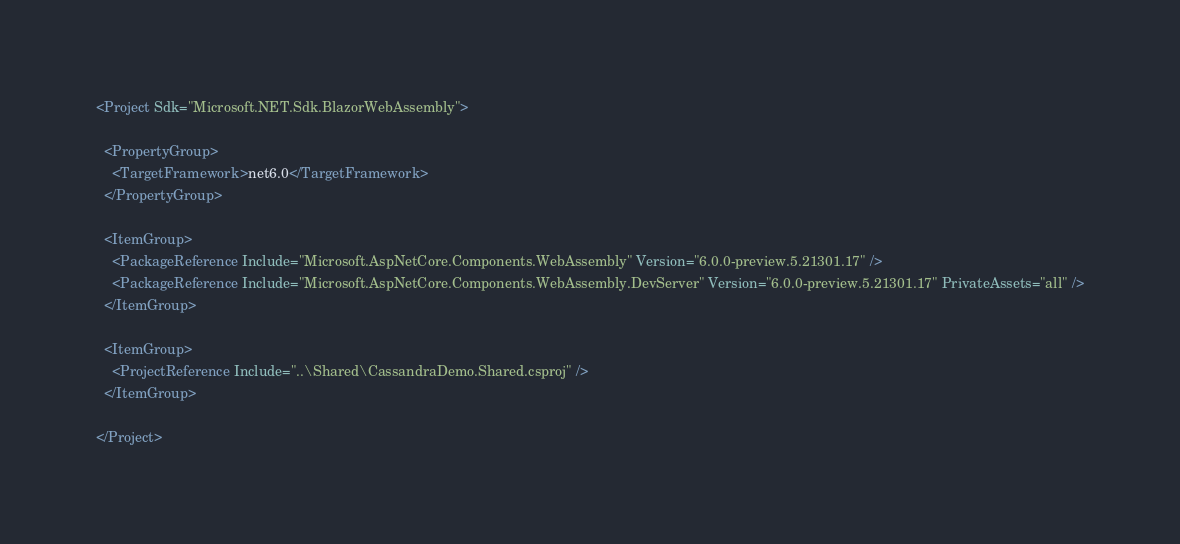<code> <loc_0><loc_0><loc_500><loc_500><_XML_><Project Sdk="Microsoft.NET.Sdk.BlazorWebAssembly">

  <PropertyGroup>
    <TargetFramework>net6.0</TargetFramework>
  </PropertyGroup>

  <ItemGroup>
    <PackageReference Include="Microsoft.AspNetCore.Components.WebAssembly" Version="6.0.0-preview.5.21301.17" />
    <PackageReference Include="Microsoft.AspNetCore.Components.WebAssembly.DevServer" Version="6.0.0-preview.5.21301.17" PrivateAssets="all" />
  </ItemGroup>

  <ItemGroup>
    <ProjectReference Include="..\Shared\CassandraDemo.Shared.csproj" />
  </ItemGroup>

</Project>
</code> 